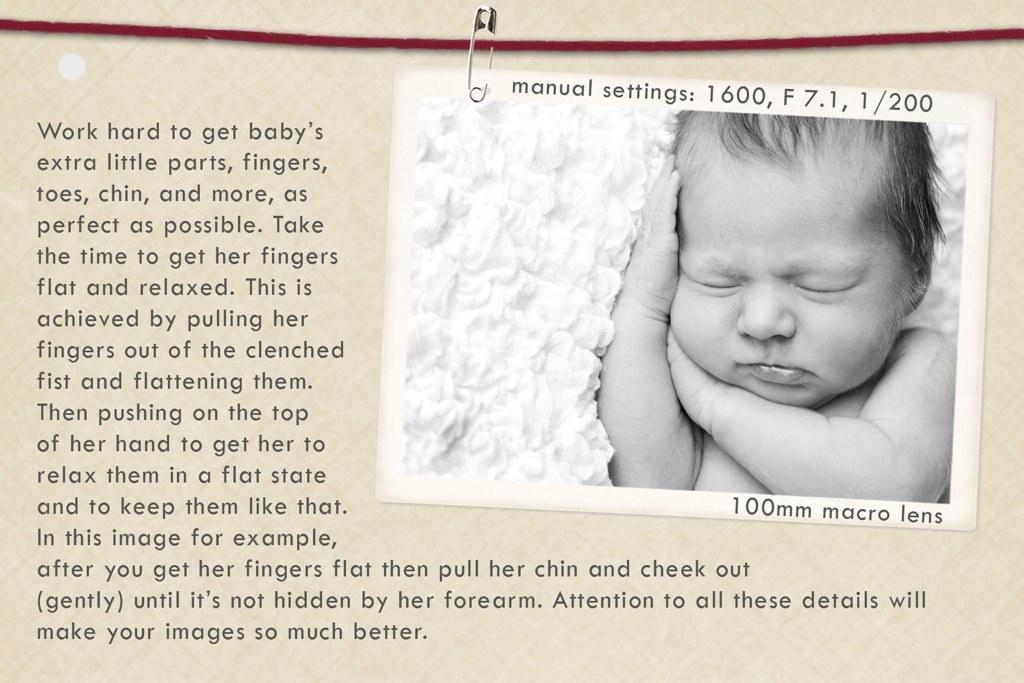How would you summarize this image in a sentence or two? In this picture we can see a paper, in the paper we can find a baby. 